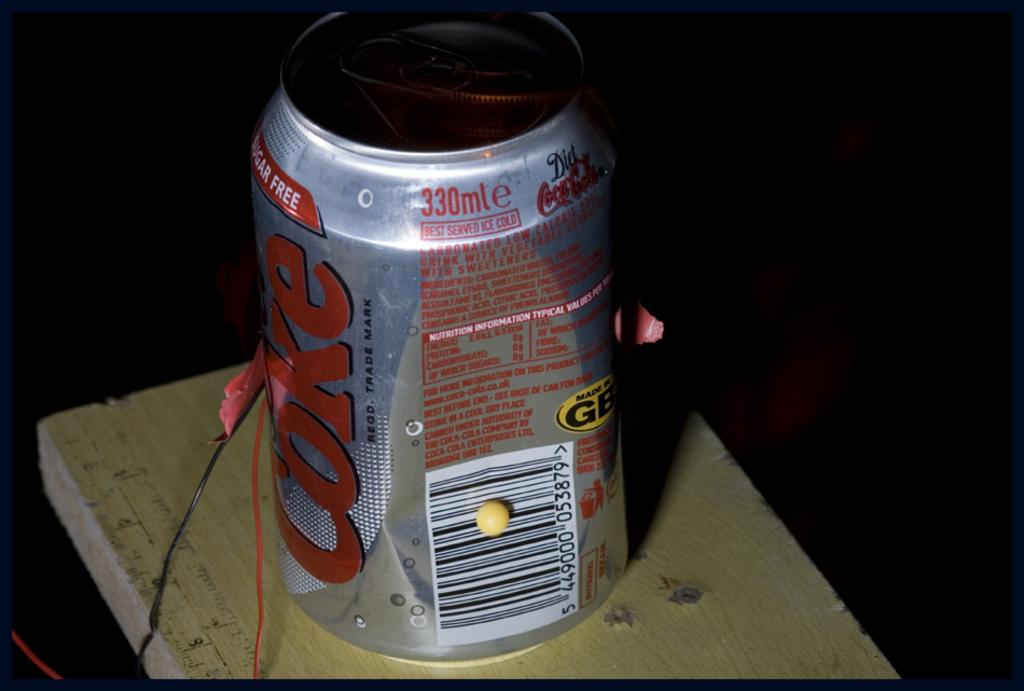Provide a one-sentence caption for the provided image. A dented diet coke can with some wires around it. 